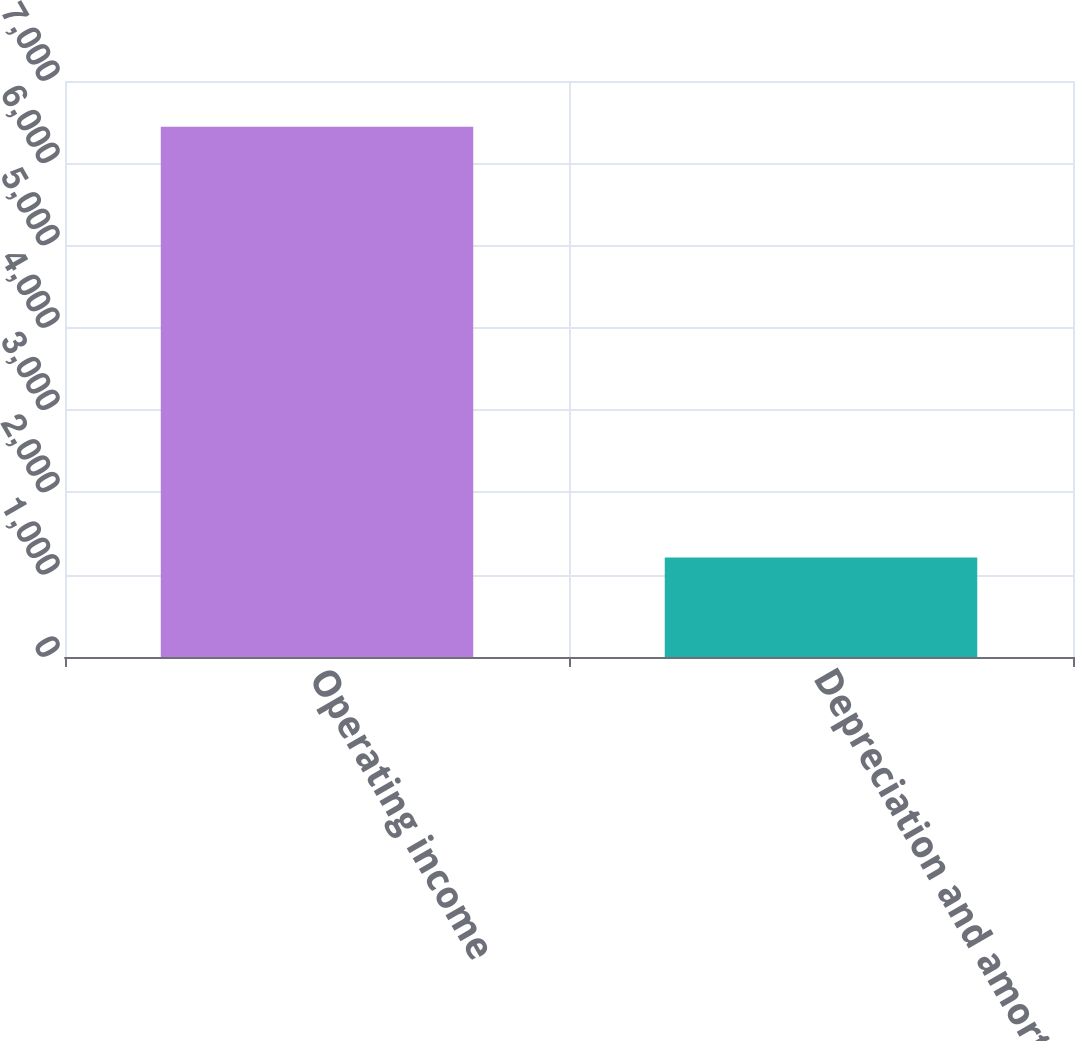Convert chart. <chart><loc_0><loc_0><loc_500><loc_500><bar_chart><fcel>Operating income<fcel>Depreciation and amortization<nl><fcel>6442.9<fcel>1207.8<nl></chart> 